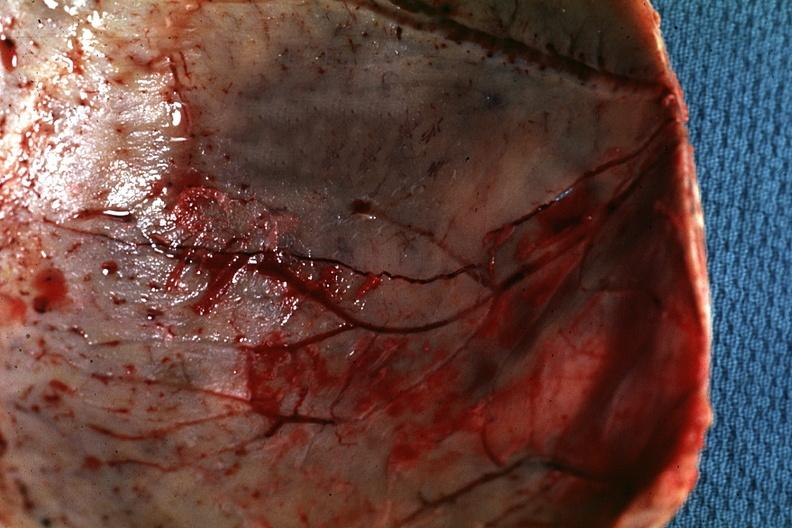what is present?
Answer the question using a single word or phrase. Fracture 